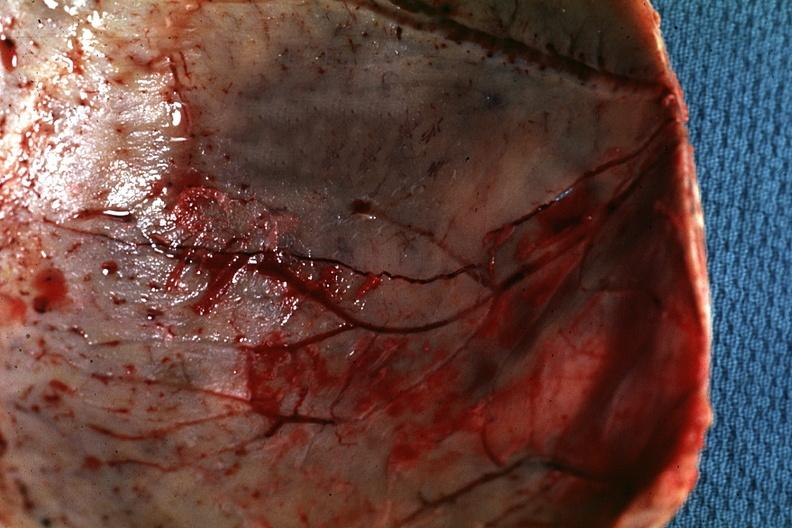what is present?
Answer the question using a single word or phrase. Fracture 